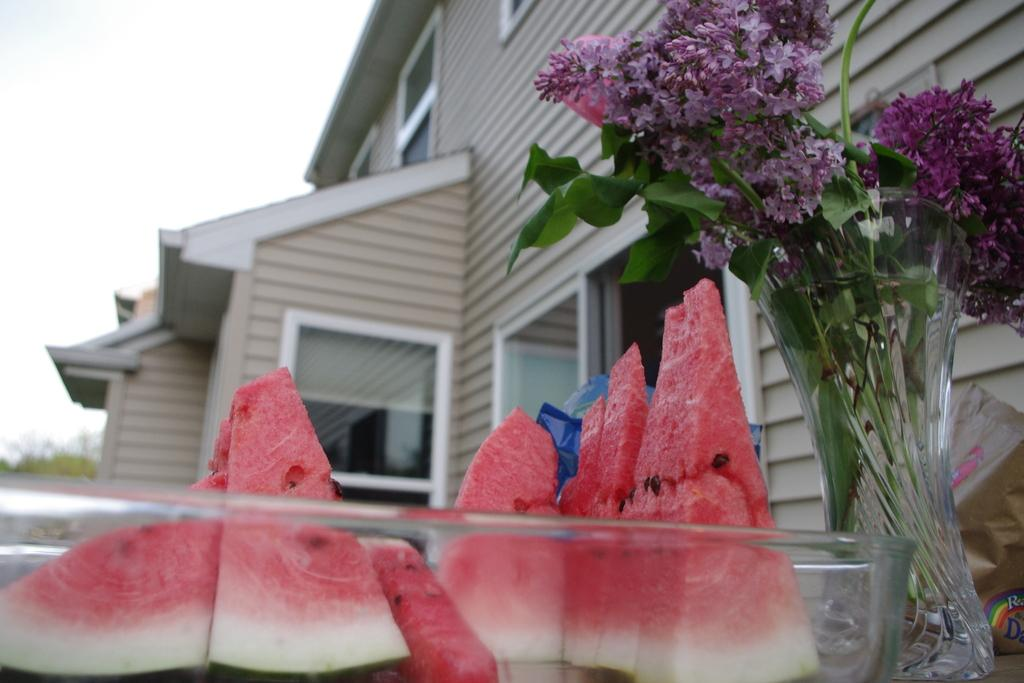What type of food is present in the image? There are watermelon slices in the image. What object is used for holding flowers in the image? There is a flower vase in the image. What type of structure can be seen in the image? There is a building visible in the image. What type of vegetation is visible in the background of the image? There are trees in the background of the image. What type of property does the cub own in the image? There is no cub or property present in the image. 